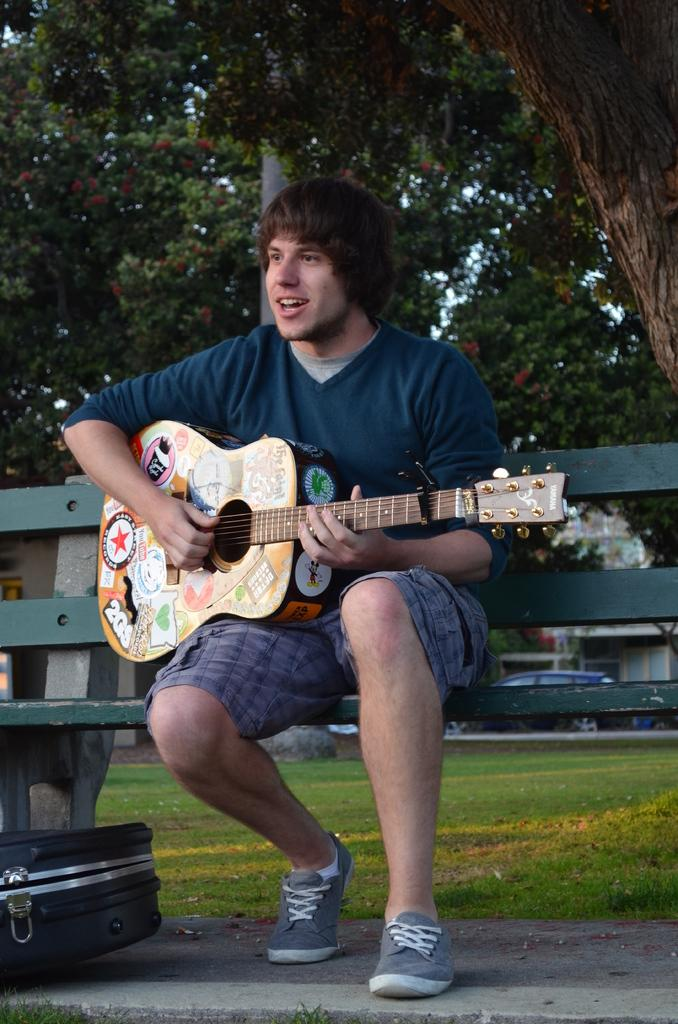What is the person in the image doing? The person is playing a guitar. What is the person wearing in the image? The person is wearing a sweatshirt. Where is the person sitting in the image? The person is sitting on a bench. What can be seen in the background of the image? There are trees, cars, and a building in the background of the image. How does the person in the image breathe while playing the guitar? The image does not show the person breathing, so it cannot be determined from the image. 